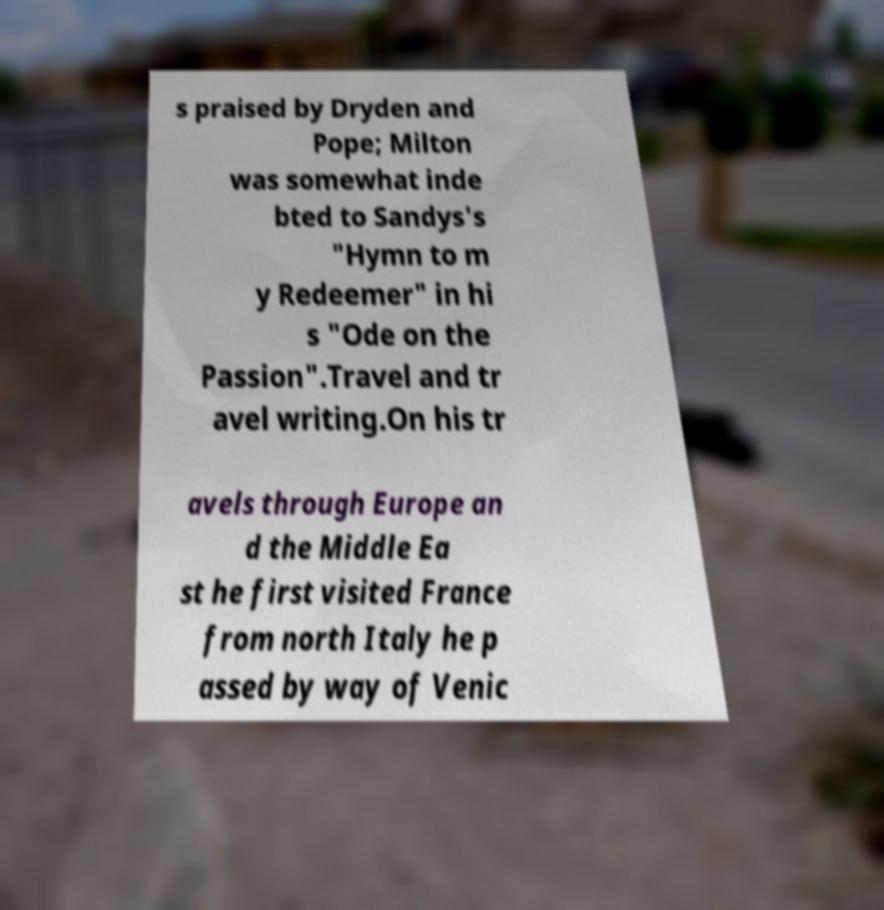For documentation purposes, I need the text within this image transcribed. Could you provide that? s praised by Dryden and Pope; Milton was somewhat inde bted to Sandys's "Hymn to m y Redeemer" in hi s "Ode on the Passion".Travel and tr avel writing.On his tr avels through Europe an d the Middle Ea st he first visited France from north Italy he p assed by way of Venic 